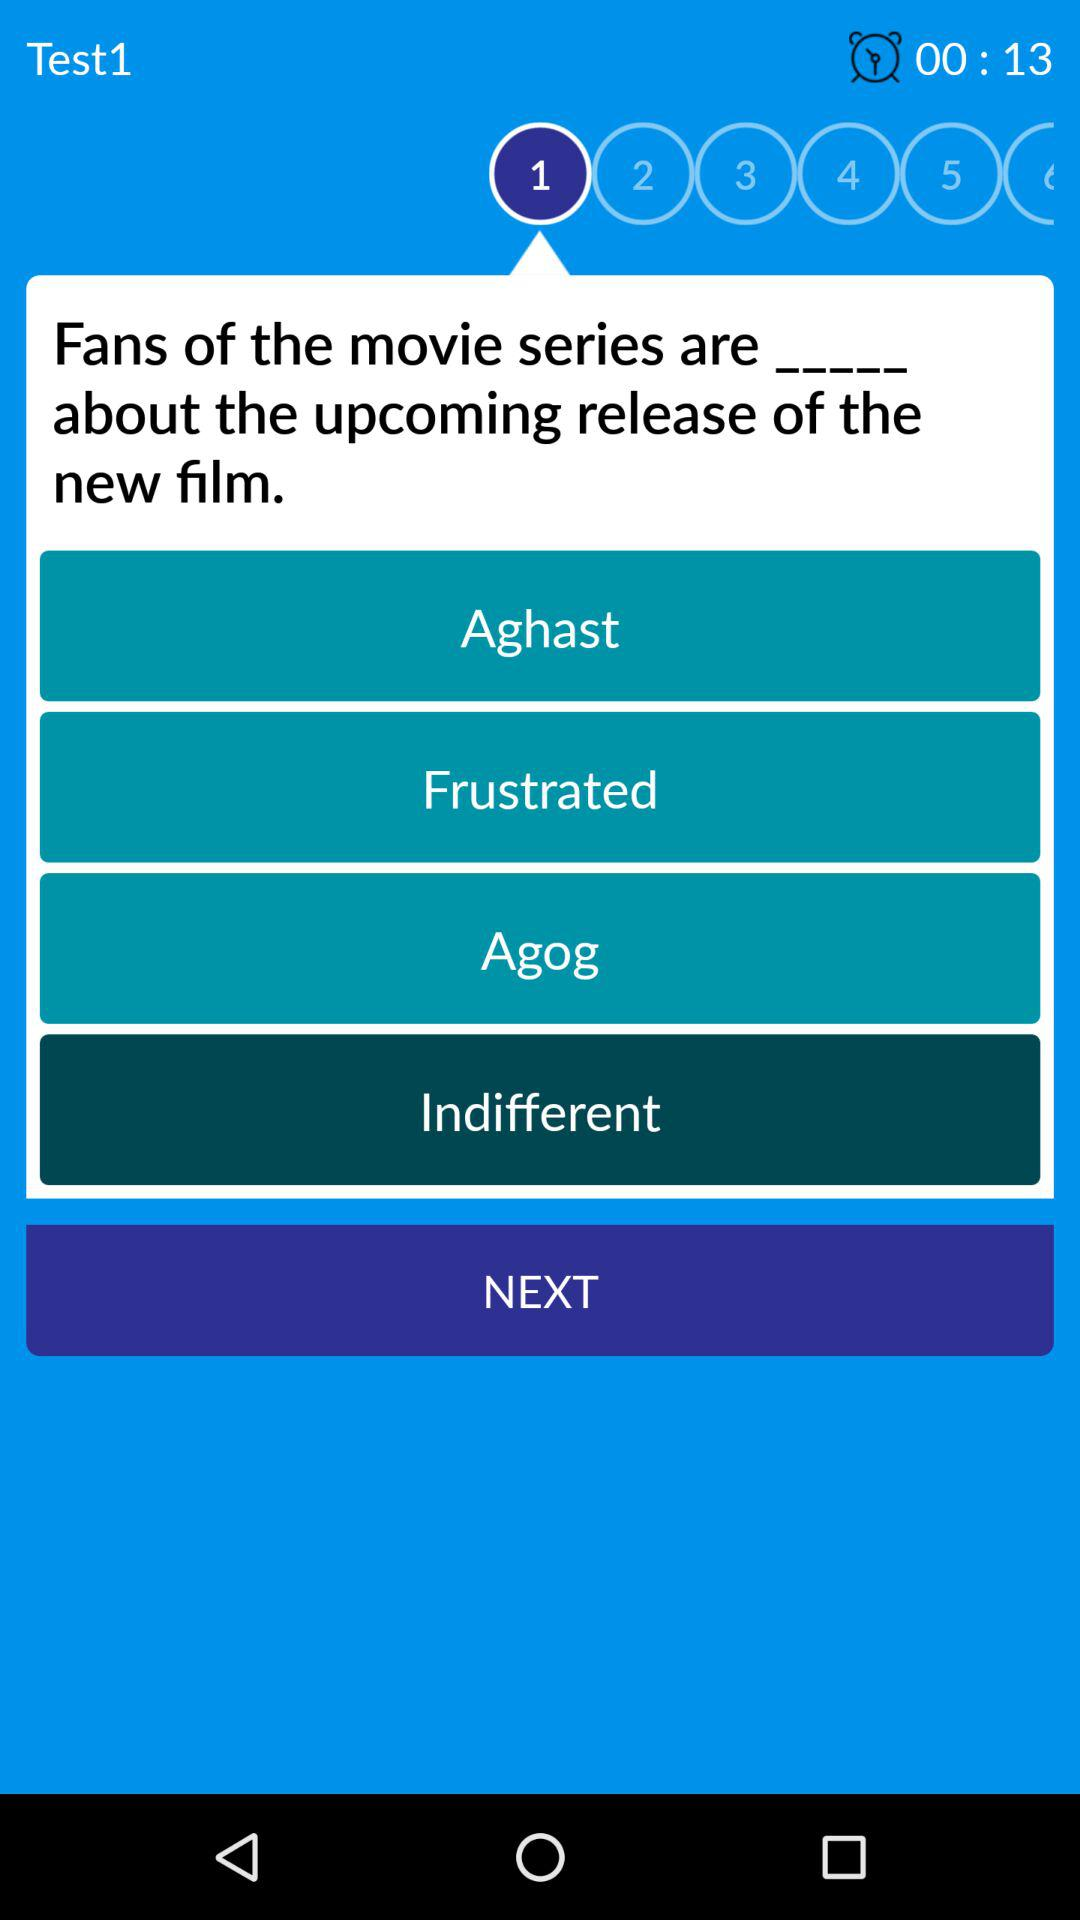What is the name of the test? The name of the test is "Test1". 